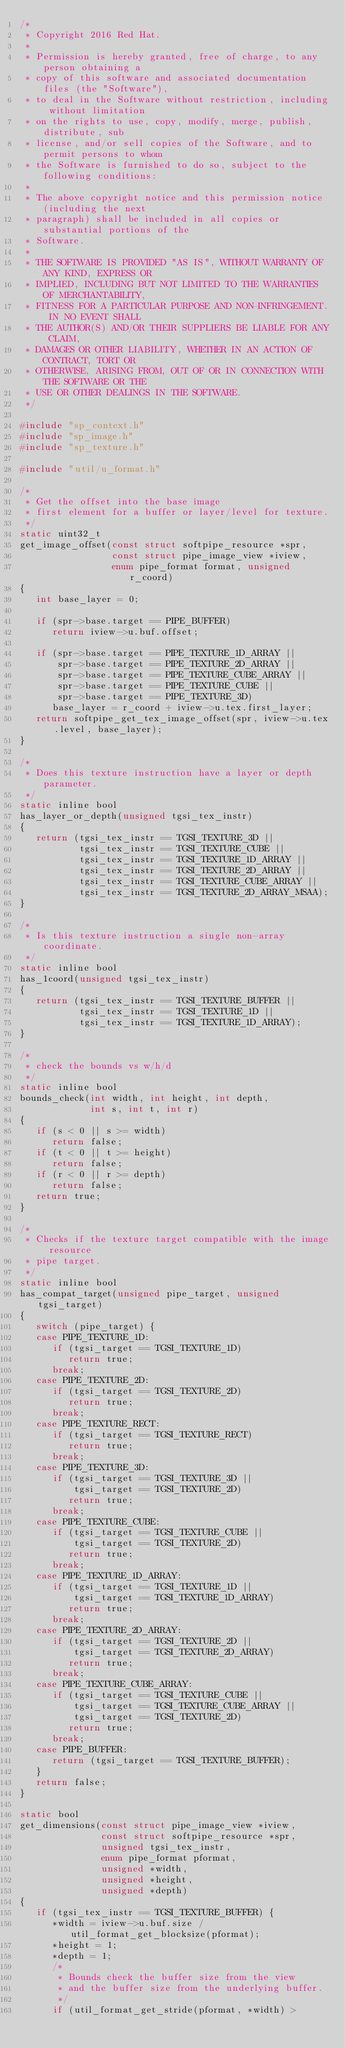<code> <loc_0><loc_0><loc_500><loc_500><_C_>/*
 * Copyright 2016 Red Hat.
 *
 * Permission is hereby granted, free of charge, to any person obtaining a
 * copy of this software and associated documentation files (the "Software"),
 * to deal in the Software without restriction, including without limitation
 * on the rights to use, copy, modify, merge, publish, distribute, sub
 * license, and/or sell copies of the Software, and to permit persons to whom
 * the Software is furnished to do so, subject to the following conditions:
 *
 * The above copyright notice and this permission notice (including the next
 * paragraph) shall be included in all copies or substantial portions of the
 * Software.
 *
 * THE SOFTWARE IS PROVIDED "AS IS", WITHOUT WARRANTY OF ANY KIND, EXPRESS OR
 * IMPLIED, INCLUDING BUT NOT LIMITED TO THE WARRANTIES OF MERCHANTABILITY,
 * FITNESS FOR A PARTICULAR PURPOSE AND NON-INFRINGEMENT. IN NO EVENT SHALL
 * THE AUTHOR(S) AND/OR THEIR SUPPLIERS BE LIABLE FOR ANY CLAIM,
 * DAMAGES OR OTHER LIABILITY, WHETHER IN AN ACTION OF CONTRACT, TORT OR
 * OTHERWISE, ARISING FROM, OUT OF OR IN CONNECTION WITH THE SOFTWARE OR THE
 * USE OR OTHER DEALINGS IN THE SOFTWARE.
 */

#include "sp_context.h"
#include "sp_image.h"
#include "sp_texture.h"

#include "util/u_format.h"

/*
 * Get the offset into the base image
 * first element for a buffer or layer/level for texture.
 */
static uint32_t
get_image_offset(const struct softpipe_resource *spr,
                 const struct pipe_image_view *iview,
                 enum pipe_format format, unsigned r_coord)
{
   int base_layer = 0;

   if (spr->base.target == PIPE_BUFFER)
      return iview->u.buf.offset;

   if (spr->base.target == PIPE_TEXTURE_1D_ARRAY ||
       spr->base.target == PIPE_TEXTURE_2D_ARRAY ||
       spr->base.target == PIPE_TEXTURE_CUBE_ARRAY ||
       spr->base.target == PIPE_TEXTURE_CUBE ||
       spr->base.target == PIPE_TEXTURE_3D)
      base_layer = r_coord + iview->u.tex.first_layer;
   return softpipe_get_tex_image_offset(spr, iview->u.tex.level, base_layer);
}

/*
 * Does this texture instruction have a layer or depth parameter.
 */
static inline bool
has_layer_or_depth(unsigned tgsi_tex_instr)
{
   return (tgsi_tex_instr == TGSI_TEXTURE_3D ||
           tgsi_tex_instr == TGSI_TEXTURE_CUBE ||
           tgsi_tex_instr == TGSI_TEXTURE_1D_ARRAY ||
           tgsi_tex_instr == TGSI_TEXTURE_2D_ARRAY ||
           tgsi_tex_instr == TGSI_TEXTURE_CUBE_ARRAY ||
           tgsi_tex_instr == TGSI_TEXTURE_2D_ARRAY_MSAA);
}

/*
 * Is this texture instruction a single non-array coordinate.
 */
static inline bool
has_1coord(unsigned tgsi_tex_instr)
{
   return (tgsi_tex_instr == TGSI_TEXTURE_BUFFER ||
           tgsi_tex_instr == TGSI_TEXTURE_1D ||
           tgsi_tex_instr == TGSI_TEXTURE_1D_ARRAY);
}

/*
 * check the bounds vs w/h/d
 */
static inline bool
bounds_check(int width, int height, int depth,
             int s, int t, int r)
{
   if (s < 0 || s >= width)
      return false;
   if (t < 0 || t >= height)
      return false;
   if (r < 0 || r >= depth)
      return false;
   return true;
}

/*
 * Checks if the texture target compatible with the image resource
 * pipe target.
 */
static inline bool
has_compat_target(unsigned pipe_target, unsigned tgsi_target)
{
   switch (pipe_target) {
   case PIPE_TEXTURE_1D:
      if (tgsi_target == TGSI_TEXTURE_1D)
         return true;
      break;
   case PIPE_TEXTURE_2D:
      if (tgsi_target == TGSI_TEXTURE_2D)
         return true;
      break;
   case PIPE_TEXTURE_RECT:
      if (tgsi_target == TGSI_TEXTURE_RECT)
         return true;
      break;
   case PIPE_TEXTURE_3D:
      if (tgsi_target == TGSI_TEXTURE_3D ||
          tgsi_target == TGSI_TEXTURE_2D)
         return true;
      break;
   case PIPE_TEXTURE_CUBE:
      if (tgsi_target == TGSI_TEXTURE_CUBE ||
          tgsi_target == TGSI_TEXTURE_2D)
         return true;
      break;
   case PIPE_TEXTURE_1D_ARRAY:
      if (tgsi_target == TGSI_TEXTURE_1D ||
          tgsi_target == TGSI_TEXTURE_1D_ARRAY)
         return true;
      break;
   case PIPE_TEXTURE_2D_ARRAY:
      if (tgsi_target == TGSI_TEXTURE_2D ||
          tgsi_target == TGSI_TEXTURE_2D_ARRAY)
         return true;
      break;
   case PIPE_TEXTURE_CUBE_ARRAY:
      if (tgsi_target == TGSI_TEXTURE_CUBE ||
          tgsi_target == TGSI_TEXTURE_CUBE_ARRAY ||
          tgsi_target == TGSI_TEXTURE_2D)
         return true;
      break;
   case PIPE_BUFFER:
      return (tgsi_target == TGSI_TEXTURE_BUFFER);
   }
   return false;
}

static bool
get_dimensions(const struct pipe_image_view *iview,
               const struct softpipe_resource *spr,
               unsigned tgsi_tex_instr,
               enum pipe_format pformat,
               unsigned *width,
               unsigned *height,
               unsigned *depth)
{
   if (tgsi_tex_instr == TGSI_TEXTURE_BUFFER) {
      *width = iview->u.buf.size / util_format_get_blocksize(pformat);
      *height = 1;
      *depth = 1;
      /*
       * Bounds check the buffer size from the view
       * and the buffer size from the underlying buffer.
       */
      if (util_format_get_stride(pformat, *width) ></code> 